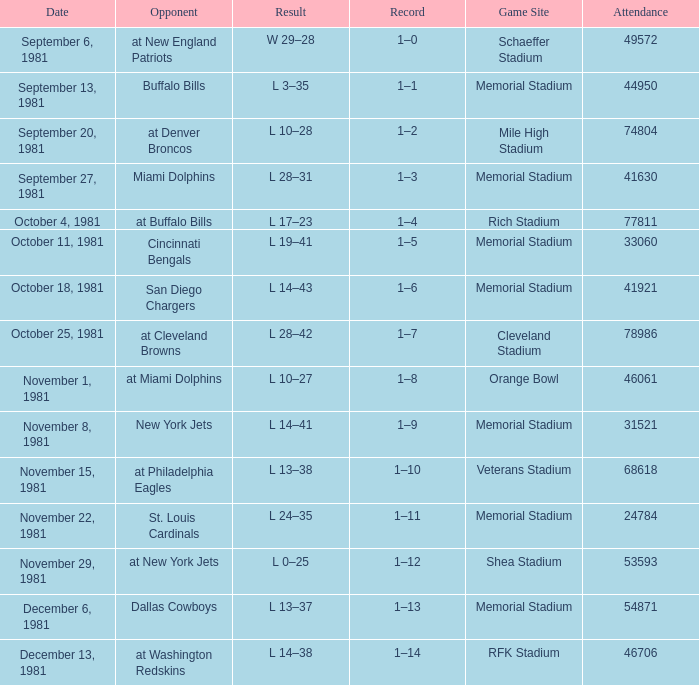When it is October 18, 1981 where is the game site? Memorial Stadium. 